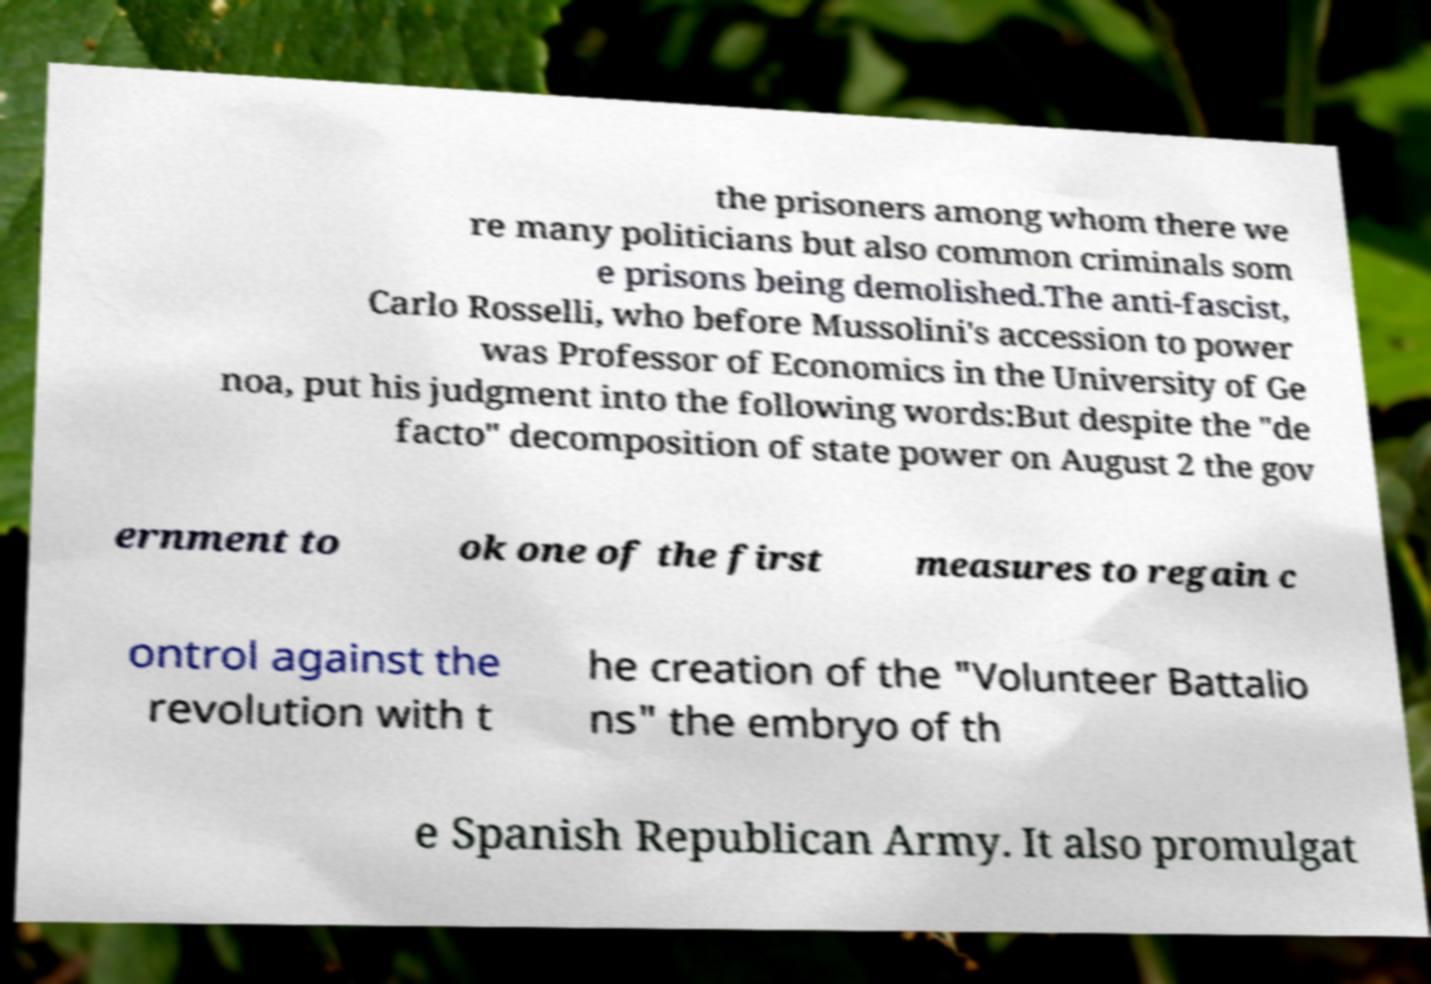Please read and relay the text visible in this image. What does it say? the prisoners among whom there we re many politicians but also common criminals som e prisons being demolished.The anti-fascist, Carlo Rosselli, who before Mussolini's accession to power was Professor of Economics in the University of Ge noa, put his judgment into the following words:But despite the "de facto" decomposition of state power on August 2 the gov ernment to ok one of the first measures to regain c ontrol against the revolution with t he creation of the "Volunteer Battalio ns" the embryo of th e Spanish Republican Army. It also promulgat 